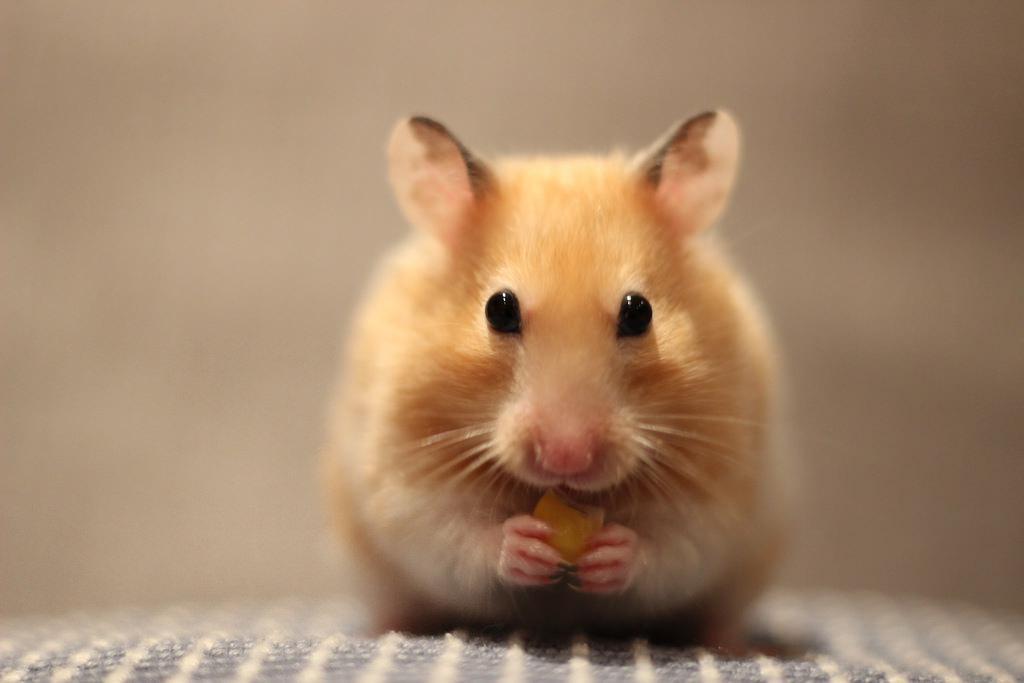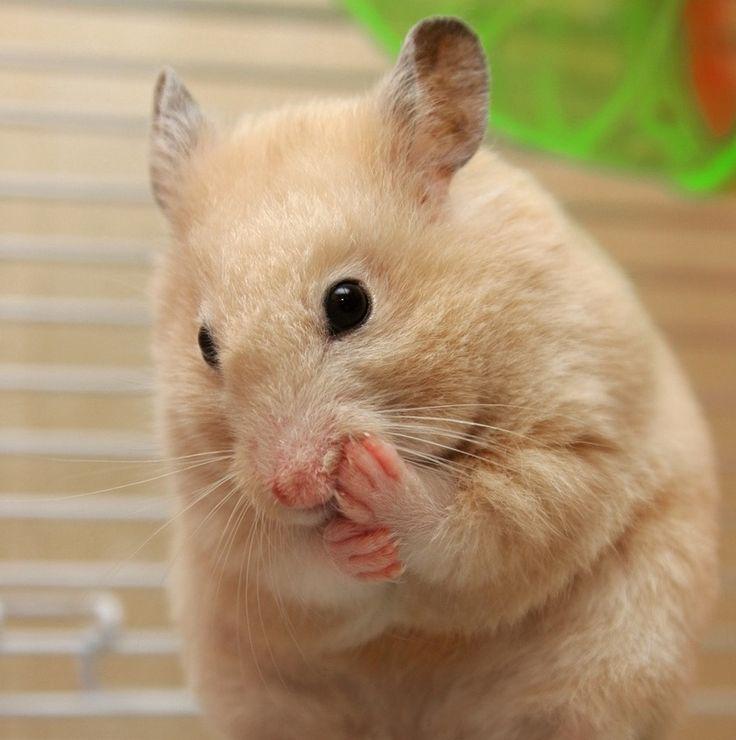The first image is the image on the left, the second image is the image on the right. Assess this claim about the two images: "In one image, a hamster is holding a bit of corn in its hands.". Correct or not? Answer yes or no. Yes. The first image is the image on the left, the second image is the image on the right. Given the left and right images, does the statement "One hamster is eating a single kernel of corn." hold true? Answer yes or no. Yes. 